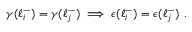<formula> <loc_0><loc_0><loc_500><loc_500>\begin{array} { r } { \gamma ( \ell _ { i } ^ { - } ) = \gamma ( \ell _ { j } ^ { - } ) \implies \epsilon ( \ell _ { i } ^ { - } ) = \epsilon ( \ell _ { j } ^ { - } ) . } \end{array}</formula> 